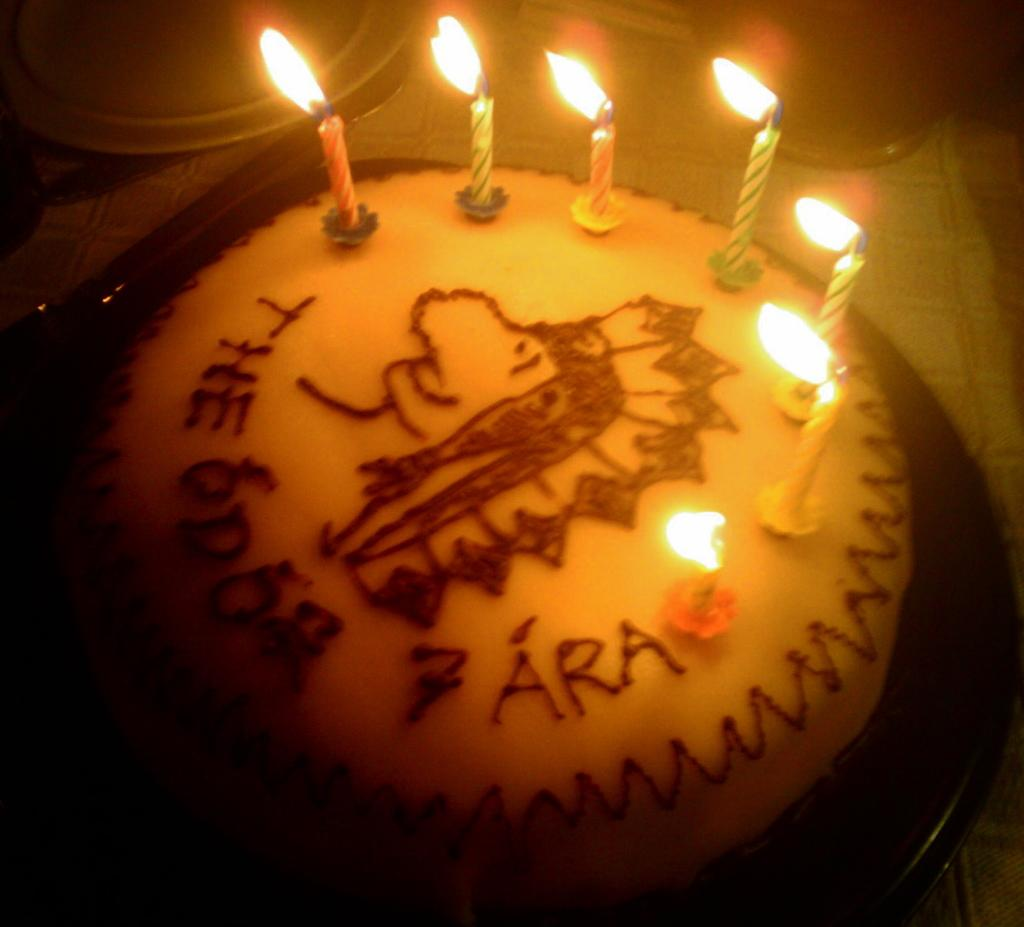What is the main subject of the image? There is a cake in the image. What is placed on top of the cake? There are candles on the cake. What tool is visible in the image? There is a knife in the image. What piece of furniture is present in the image? There is a table in the image. How are some objects in the image represented? Some objects are truncated towards the top of the image, which means they are partially visible or cut off at the top. What type of hall can be seen in the image? There is no hall present in the image; it features a cake with candles and a knife on a table. How does the mind interact with the cake in the image? The image does not depict any interaction with the cake by a mind or any mental activity; it is a static representation of a cake with candles and a knife on a table. 